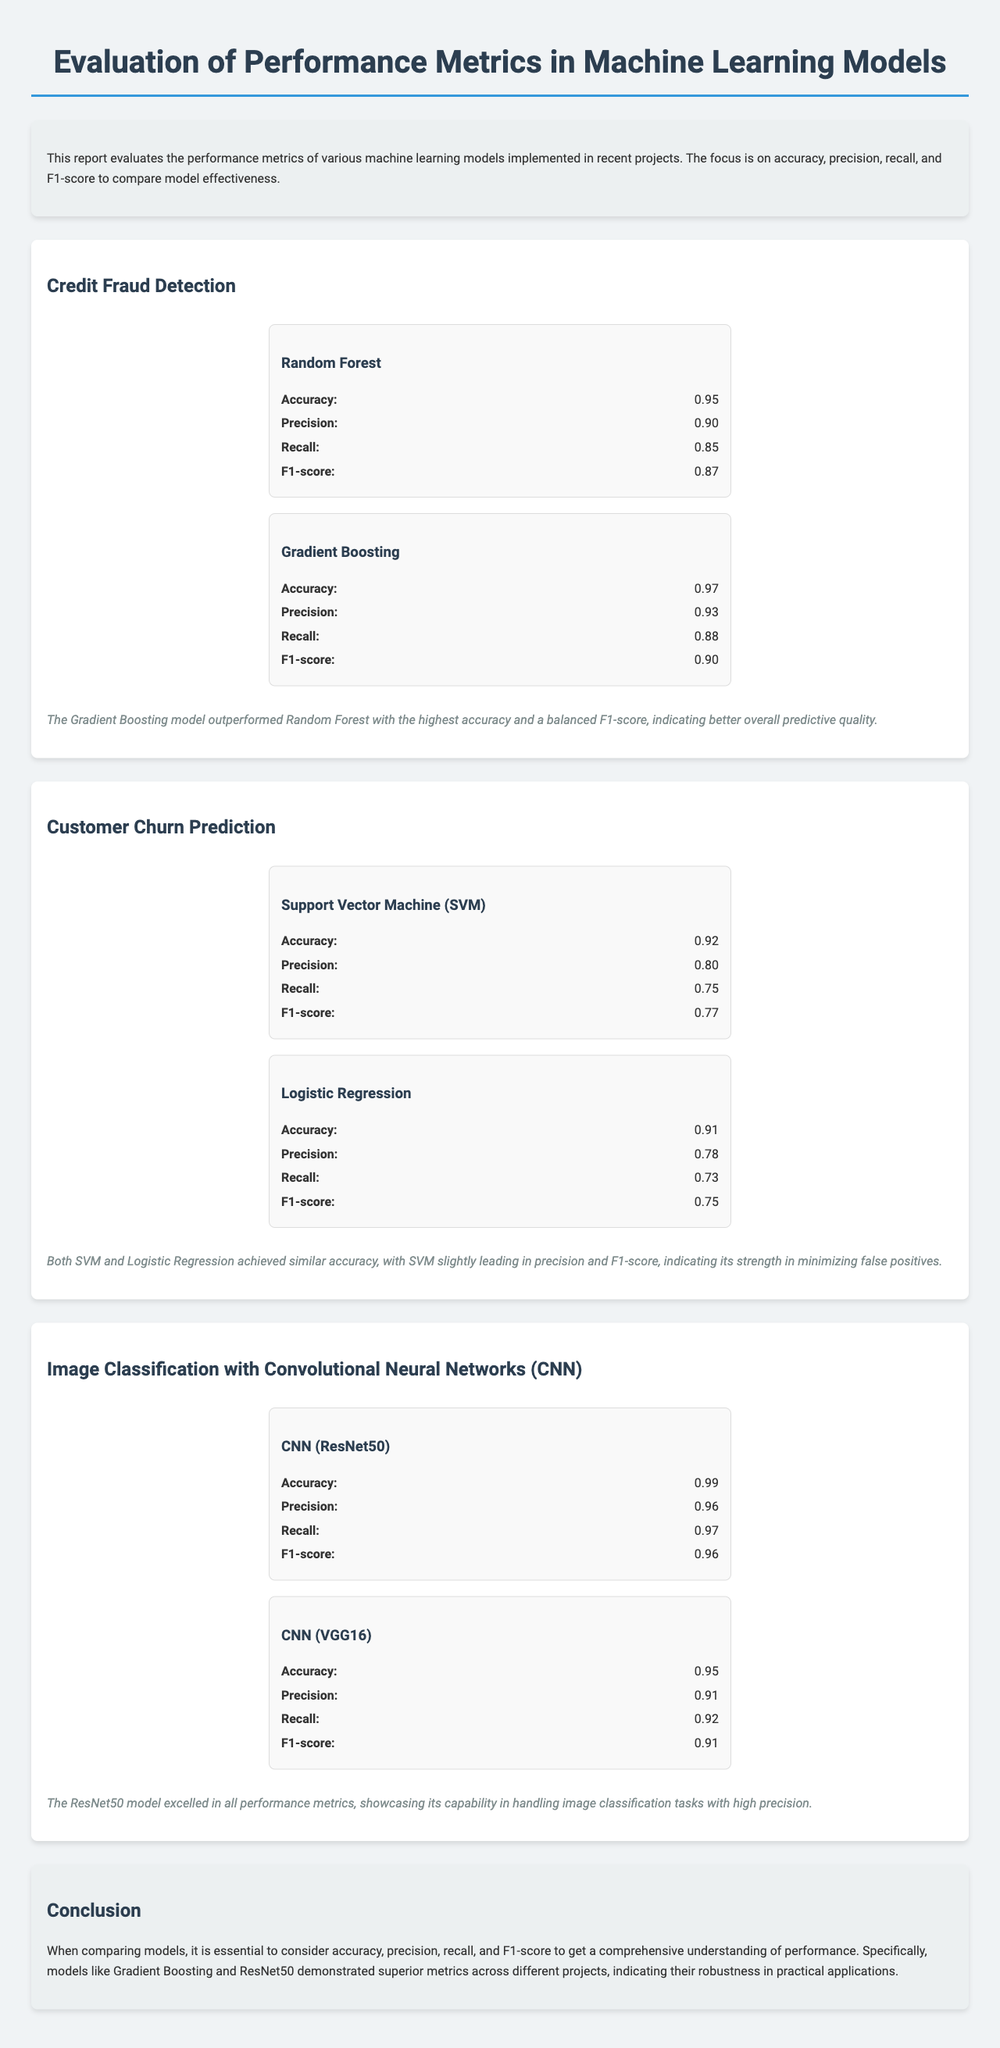What is the accuracy of the Random Forest model in Credit Fraud Detection? The accuracy is a specific performance metric provided for the Random Forest model in the Credit Fraud Detection section, which is 0.95.
Answer: 0.95 Which model had the highest F1-score in Credit Fraud Detection? The F1-score is a comparative metric between models; according to the summary, the Gradient Boosting model had the highest F1-score of 0.90.
Answer: Gradient Boosting What was the precision of the SVM model in Customer Churn Prediction? The precision is a statistic found in the Customer Churn Prediction section for SVM, listed as 0.80.
Answer: 0.80 What conclusion is drawn about the models based on the performance metrics? The conclusion summarizes the comparative performance metrics, specifically noting that Gradient Boosting and ResNet50 demonstrated superior metrics across projects.
Answer: Superior metrics What is the recall of the CNN (ResNet50) model? Recall is a performance metric listed for the CNN (ResNet50) model in the Image Classification section, which is 0.97.
Answer: 0.97 Which two models had similar accuracy in Customer Churn Prediction? The section notes that both SVM and Logistic Regression achieved similar accuracy metrics, providing clarity on their performance comparison.
Answer: SVM and Logistic Regression What background information precedes the performance evaluations? The introduction provides context about the purpose of the report, focusing on evaluation metrics for machine learning models; it serves as an overview to prepare the reader.
Answer: Overview of performance metrics Which model outperformed others in all metrics for image classification? According to the summary for the Image Classification section, ResNet50 outperformed all other models in the evaluation.
Answer: ResNet50 